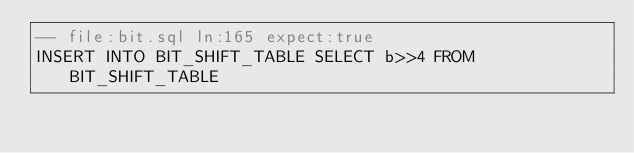<code> <loc_0><loc_0><loc_500><loc_500><_SQL_>-- file:bit.sql ln:165 expect:true
INSERT INTO BIT_SHIFT_TABLE SELECT b>>4 FROM BIT_SHIFT_TABLE
</code> 